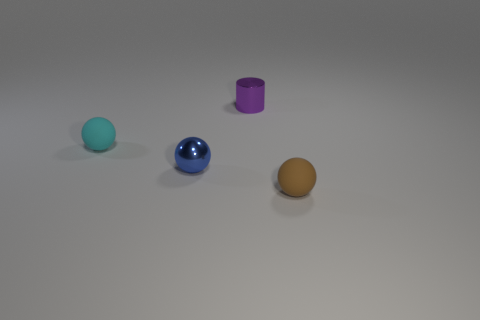Subtract all tiny shiny spheres. How many spheres are left? 2 Add 1 blue metallic balls. How many objects exist? 5 Subtract all green spheres. Subtract all purple cylinders. How many spheres are left? 3 Subtract all spheres. How many objects are left? 1 Subtract 0 cyan cylinders. How many objects are left? 4 Subtract all tiny purple metallic things. Subtract all purple objects. How many objects are left? 2 Add 2 small blue shiny objects. How many small blue shiny objects are left? 3 Add 3 tiny blue metallic objects. How many tiny blue metallic objects exist? 4 